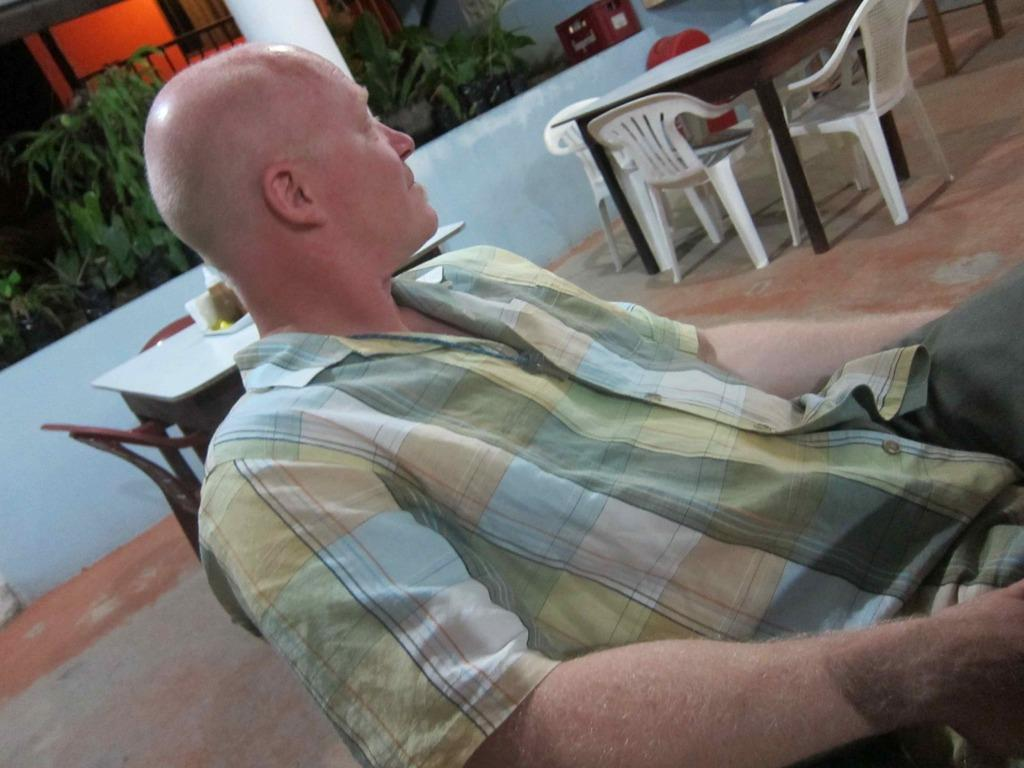What is the man in the image doing? The man is sitting in the image. What can be seen in the background of the image? There are tables and chairs, planets, and a wall visible in the background of the image. What type of creature is sitting on the throne in the image? There is no throne present in the image, and therefore no creature sitting on it. 